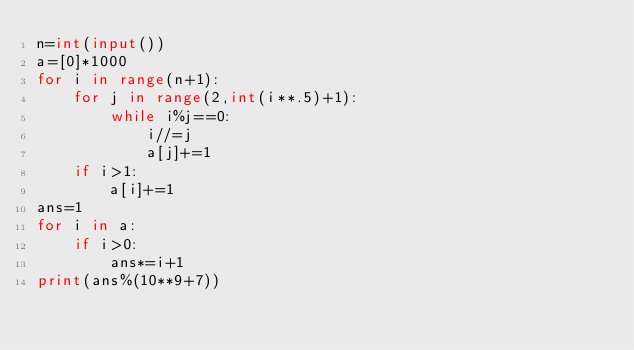<code> <loc_0><loc_0><loc_500><loc_500><_Python_>n=int(input())
a=[0]*1000
for i in range(n+1):
    for j in range(2,int(i**.5)+1):
        while i%j==0:
            i//=j
            a[j]+=1
    if i>1:
        a[i]+=1
ans=1        
for i in a:
    if i>0:
        ans*=i+1
print(ans%(10**9+7))</code> 